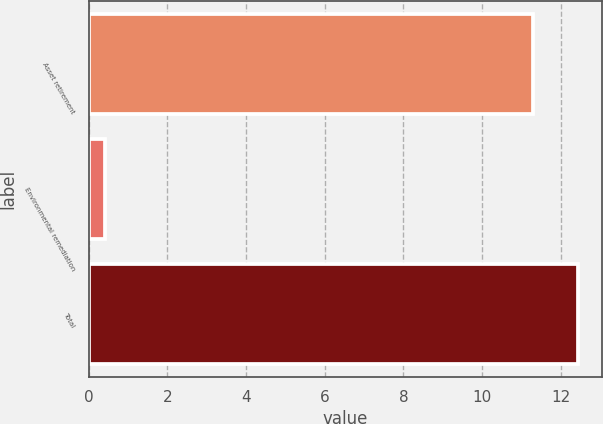<chart> <loc_0><loc_0><loc_500><loc_500><bar_chart><fcel>Asset retirement<fcel>Environmental remediation<fcel>Total<nl><fcel>11.3<fcel>0.4<fcel>12.43<nl></chart> 